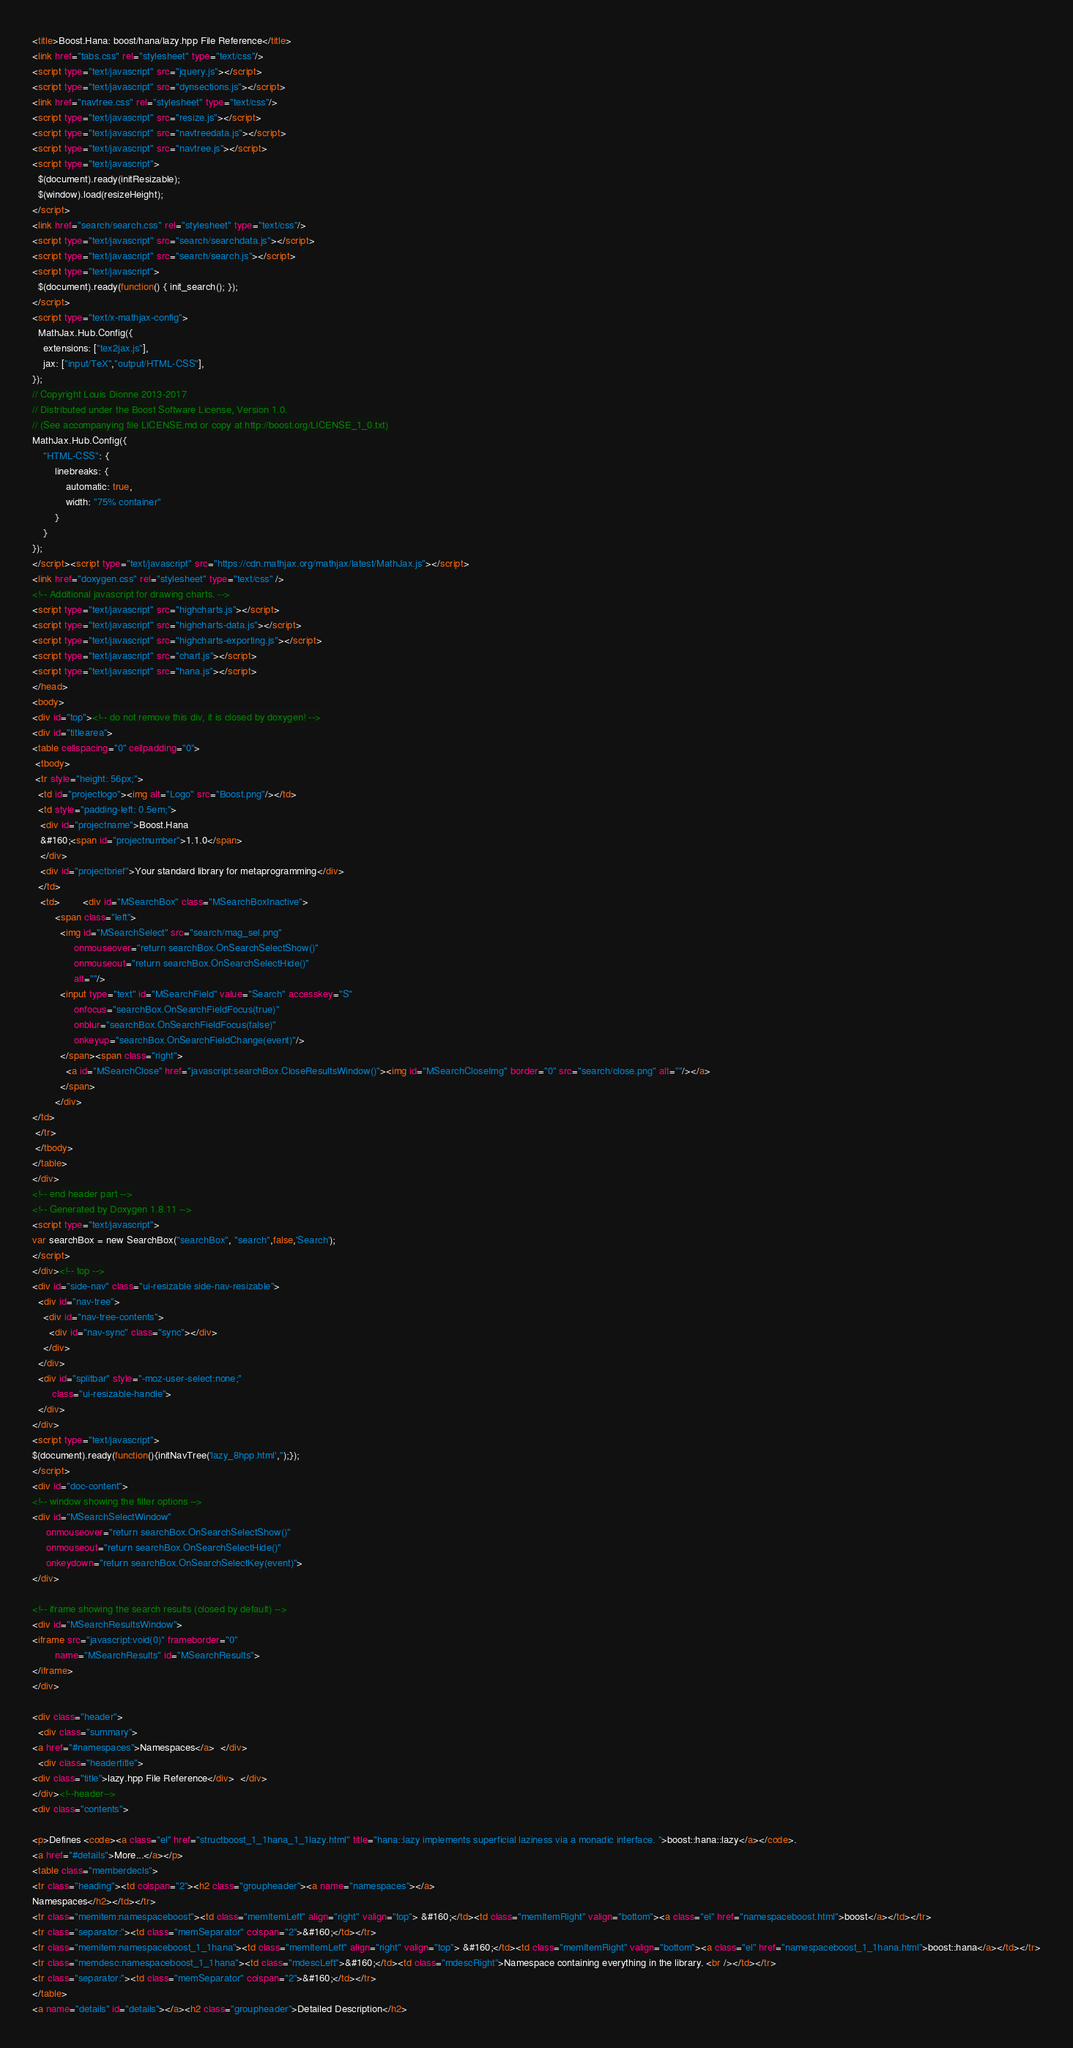<code> <loc_0><loc_0><loc_500><loc_500><_HTML_><title>Boost.Hana: boost/hana/lazy.hpp File Reference</title>
<link href="tabs.css" rel="stylesheet" type="text/css"/>
<script type="text/javascript" src="jquery.js"></script>
<script type="text/javascript" src="dynsections.js"></script>
<link href="navtree.css" rel="stylesheet" type="text/css"/>
<script type="text/javascript" src="resize.js"></script>
<script type="text/javascript" src="navtreedata.js"></script>
<script type="text/javascript" src="navtree.js"></script>
<script type="text/javascript">
  $(document).ready(initResizable);
  $(window).load(resizeHeight);
</script>
<link href="search/search.css" rel="stylesheet" type="text/css"/>
<script type="text/javascript" src="search/searchdata.js"></script>
<script type="text/javascript" src="search/search.js"></script>
<script type="text/javascript">
  $(document).ready(function() { init_search(); });
</script>
<script type="text/x-mathjax-config">
  MathJax.Hub.Config({
    extensions: ["tex2jax.js"],
    jax: ["input/TeX","output/HTML-CSS"],
});
// Copyright Louis Dionne 2013-2017
// Distributed under the Boost Software License, Version 1.0.
// (See accompanying file LICENSE.md or copy at http://boost.org/LICENSE_1_0.txt)
MathJax.Hub.Config({
    "HTML-CSS": {
        linebreaks: {
            automatic: true,
            width: "75% container"
        }
    }
});
</script><script type="text/javascript" src="https://cdn.mathjax.org/mathjax/latest/MathJax.js"></script>
<link href="doxygen.css" rel="stylesheet" type="text/css" />
<!-- Additional javascript for drawing charts. -->
<script type="text/javascript" src="highcharts.js"></script>
<script type="text/javascript" src="highcharts-data.js"></script>
<script type="text/javascript" src="highcharts-exporting.js"></script>
<script type="text/javascript" src="chart.js"></script>
<script type="text/javascript" src="hana.js"></script>
</head>
<body>
<div id="top"><!-- do not remove this div, it is closed by doxygen! -->
<div id="titlearea">
<table cellspacing="0" cellpadding="0">
 <tbody>
 <tr style="height: 56px;">
  <td id="projectlogo"><img alt="Logo" src="Boost.png"/></td>
  <td style="padding-left: 0.5em;">
   <div id="projectname">Boost.Hana
   &#160;<span id="projectnumber">1.1.0</span>
   </div>
   <div id="projectbrief">Your standard library for metaprogramming</div>
  </td>
   <td>        <div id="MSearchBox" class="MSearchBoxInactive">
        <span class="left">
          <img id="MSearchSelect" src="search/mag_sel.png"
               onmouseover="return searchBox.OnSearchSelectShow()"
               onmouseout="return searchBox.OnSearchSelectHide()"
               alt=""/>
          <input type="text" id="MSearchField" value="Search" accesskey="S"
               onfocus="searchBox.OnSearchFieldFocus(true)" 
               onblur="searchBox.OnSearchFieldFocus(false)" 
               onkeyup="searchBox.OnSearchFieldChange(event)"/>
          </span><span class="right">
            <a id="MSearchClose" href="javascript:searchBox.CloseResultsWindow()"><img id="MSearchCloseImg" border="0" src="search/close.png" alt=""/></a>
          </span>
        </div>
</td>
 </tr>
 </tbody>
</table>
</div>
<!-- end header part -->
<!-- Generated by Doxygen 1.8.11 -->
<script type="text/javascript">
var searchBox = new SearchBox("searchBox", "search",false,'Search');
</script>
</div><!-- top -->
<div id="side-nav" class="ui-resizable side-nav-resizable">
  <div id="nav-tree">
    <div id="nav-tree-contents">
      <div id="nav-sync" class="sync"></div>
    </div>
  </div>
  <div id="splitbar" style="-moz-user-select:none;" 
       class="ui-resizable-handle">
  </div>
</div>
<script type="text/javascript">
$(document).ready(function(){initNavTree('lazy_8hpp.html','');});
</script>
<div id="doc-content">
<!-- window showing the filter options -->
<div id="MSearchSelectWindow"
     onmouseover="return searchBox.OnSearchSelectShow()"
     onmouseout="return searchBox.OnSearchSelectHide()"
     onkeydown="return searchBox.OnSearchSelectKey(event)">
</div>

<!-- iframe showing the search results (closed by default) -->
<div id="MSearchResultsWindow">
<iframe src="javascript:void(0)" frameborder="0" 
        name="MSearchResults" id="MSearchResults">
</iframe>
</div>

<div class="header">
  <div class="summary">
<a href="#namespaces">Namespaces</a>  </div>
  <div class="headertitle">
<div class="title">lazy.hpp File Reference</div>  </div>
</div><!--header-->
<div class="contents">

<p>Defines <code><a class="el" href="structboost_1_1hana_1_1lazy.html" title="hana::lazy implements superficial laziness via a monadic interface. ">boost::hana::lazy</a></code>.  
<a href="#details">More...</a></p>
<table class="memberdecls">
<tr class="heading"><td colspan="2"><h2 class="groupheader"><a name="namespaces"></a>
Namespaces</h2></td></tr>
<tr class="memitem:namespaceboost"><td class="memItemLeft" align="right" valign="top"> &#160;</td><td class="memItemRight" valign="bottom"><a class="el" href="namespaceboost.html">boost</a></td></tr>
<tr class="separator:"><td class="memSeparator" colspan="2">&#160;</td></tr>
<tr class="memitem:namespaceboost_1_1hana"><td class="memItemLeft" align="right" valign="top"> &#160;</td><td class="memItemRight" valign="bottom"><a class="el" href="namespaceboost_1_1hana.html">boost::hana</a></td></tr>
<tr class="memdesc:namespaceboost_1_1hana"><td class="mdescLeft">&#160;</td><td class="mdescRight">Namespace containing everything in the library. <br /></td></tr>
<tr class="separator:"><td class="memSeparator" colspan="2">&#160;</td></tr>
</table>
<a name="details" id="details"></a><h2 class="groupheader">Detailed Description</h2></code> 